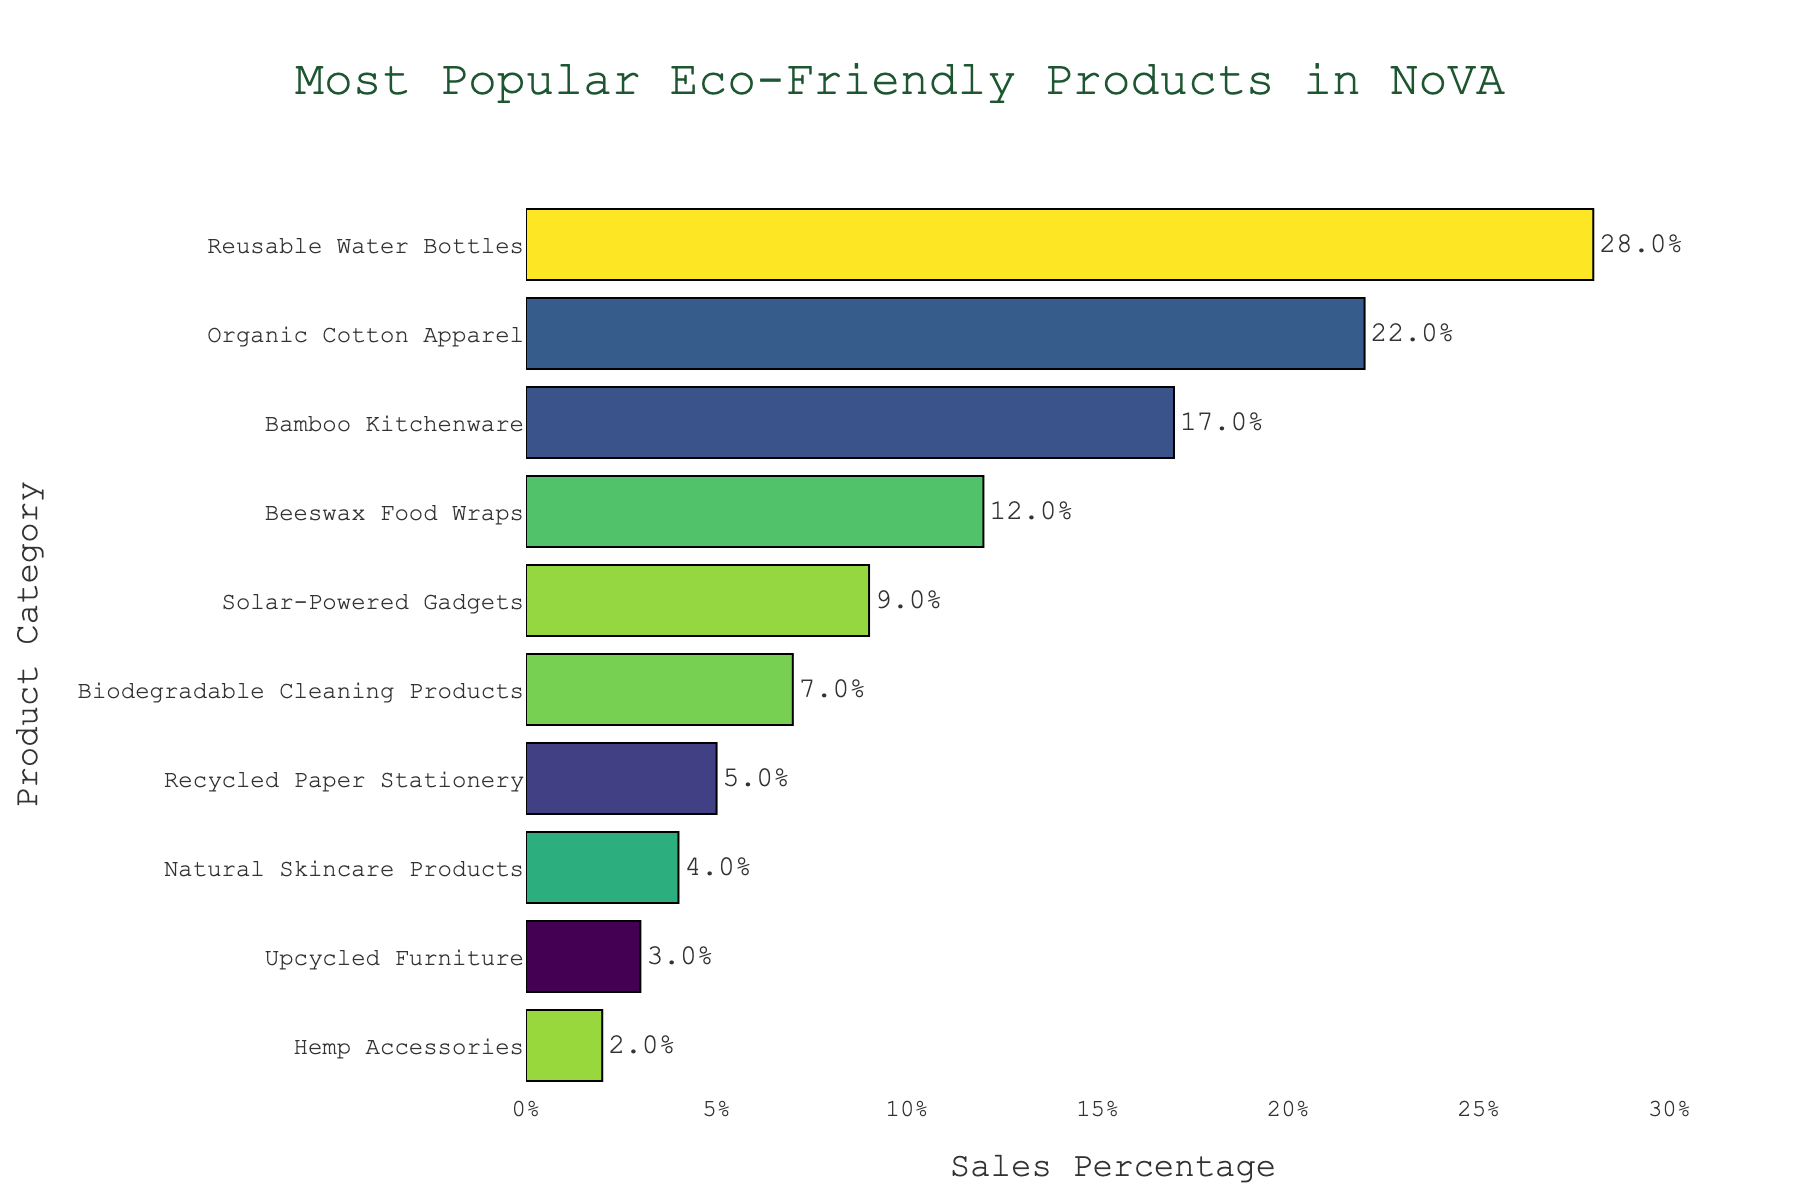What is the most popular eco-friendly product category in Northern Virginia retail stores? The bar chart shows the sales percentages of various product categories, and the one with the highest percentage is the most popular.
Answer: Reusable Water Bottles Which product category has the lowest sales percentage? By looking at the bar with the shortest length, we can identify the product category with the lowest sales percentage.
Answer: Hemp Accessories How much more popular are Reusable Water Bottles compared to Natural Skincare Products? Subtract the sales percentage of Natural Skincare Products from that of Reusable Water Bottles: 28% - 4% = 24%
Answer: 24% What is the combined sales percentage of Bamboo Kitchenware and Beeswax Food Wraps? Add the sales percentages of Bamboo Kitchenware and Beeswax Food Wraps: 17% + 12% = 29%
Answer: 29% Are Organic Cotton Apparel or Solar-Powered Gadgets more popular? Compare the sales percentages of these categories, noting that Organic Cotton Apparel has 22%, while Solar-Powered Gadgets has 9%.
Answer: Organic Cotton Apparel Is the sales percentage of Biodegradable Cleaning Products greater than that of Recycled Paper Stationery? Compare the bars for Biodegradable Cleaning Products and Recycled Paper Stationery, noting that Biodegradable Cleaning Products has 7% and Recycled Paper Stationery has 5%.
Answer: Yes What is the average sales percentage of the top three product categories? First, find the top three product categories, then calculate their average sales percentage: (28% + 22% + 17%) / 3 = 22.33%
Answer: 22.33% By how much does the sales percentage of Reusable Water Bottles exceed that of the second most popular product category? Subtract the sales percentage of Organic Cotton Apparel from that of Reusable Water Bottles: 28% - 22% = 6%
Answer: 6% How do the sales percentages of Beeswax Food Wraps and Solar-Powered Gadgets compare? Compare the bars for these two categories, noting that Beeswax Food Wraps have a sales percentage of 12%, while Solar-Powered Gadgets have 9%.
Answer: Beeswax Food Wraps are more popular What is the combined sales percentage for the four least popular product categories? Add the sales percentages of the four least popular categories: (Hemp Accessories + Upcycled Furniture + Natural Skincare Products + Recycled Paper Stationery) = 2% + 3% + 4% + 5% = 14%
Answer: 14% 